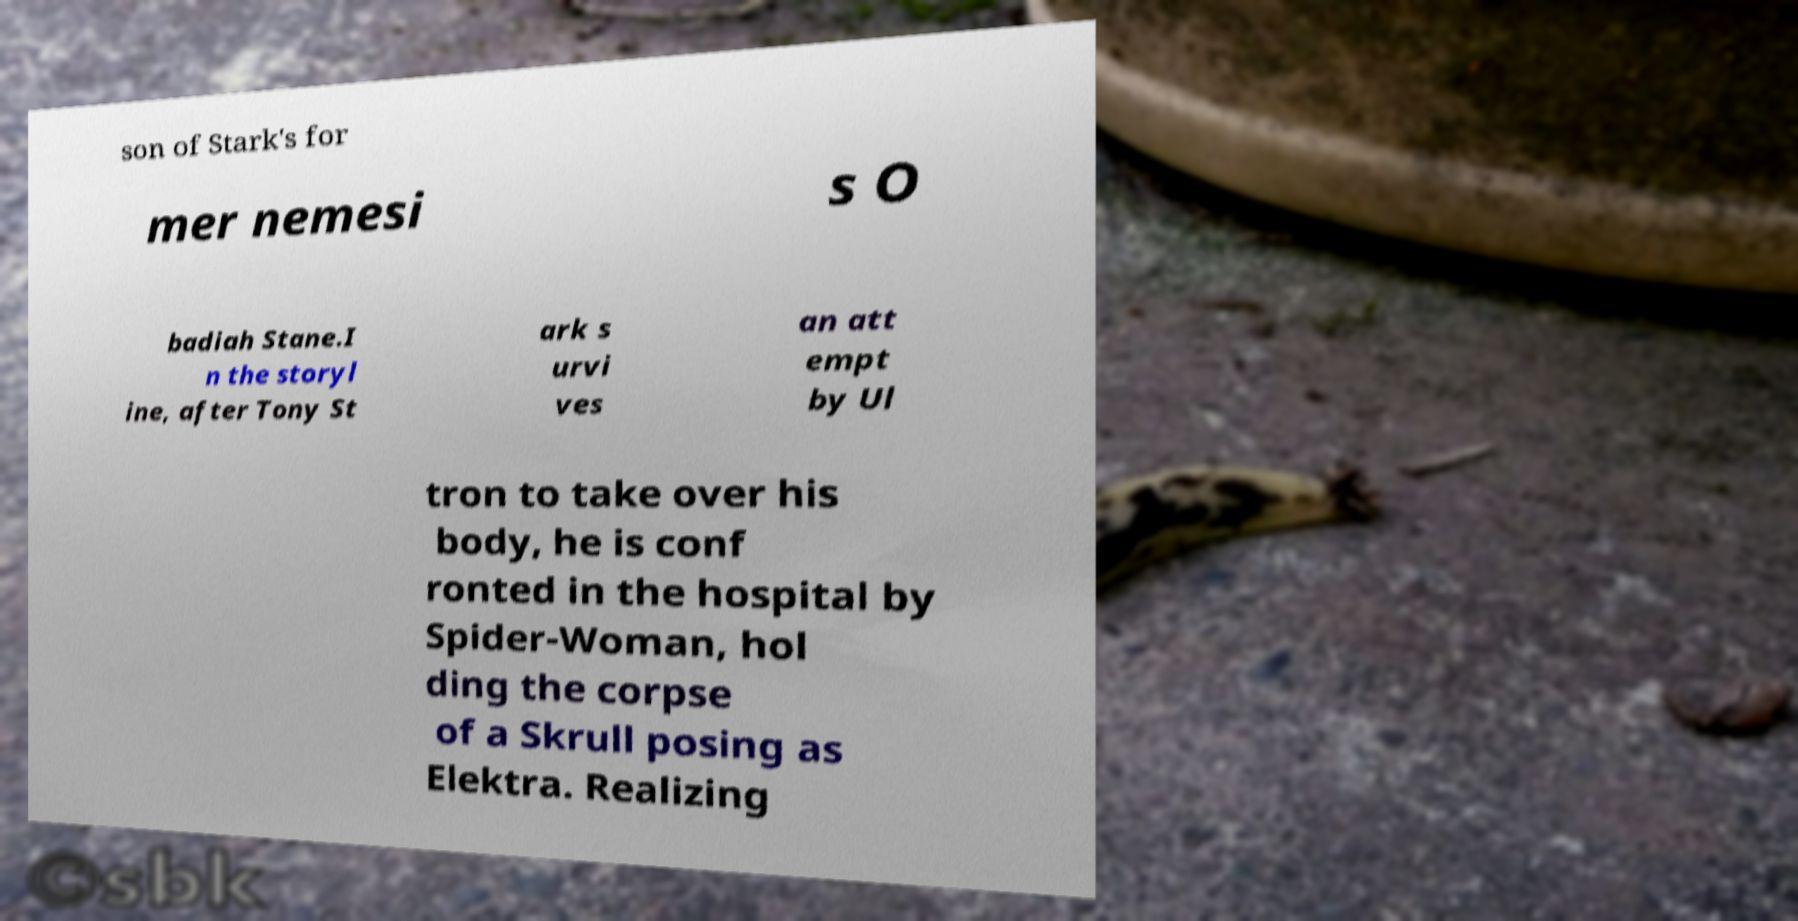Can you accurately transcribe the text from the provided image for me? son of Stark's for mer nemesi s O badiah Stane.I n the storyl ine, after Tony St ark s urvi ves an att empt by Ul tron to take over his body, he is conf ronted in the hospital by Spider-Woman, hol ding the corpse of a Skrull posing as Elektra. Realizing 